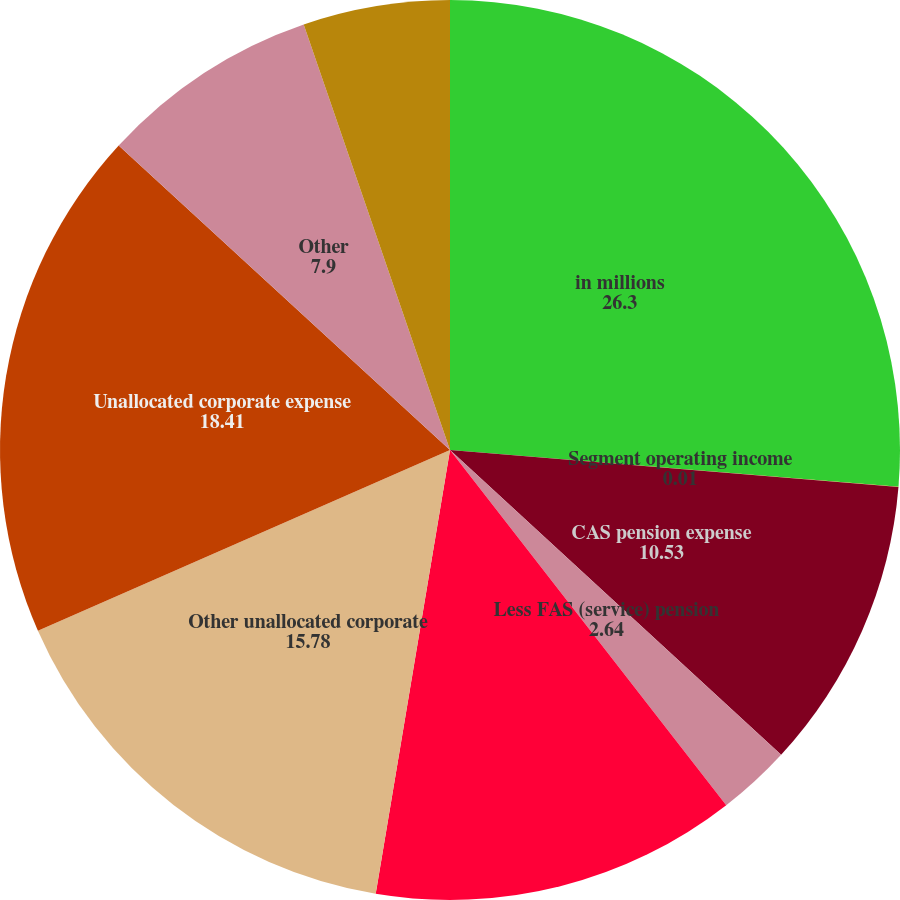Convert chart. <chart><loc_0><loc_0><loc_500><loc_500><pie_chart><fcel>in millions<fcel>Segment operating income<fcel>CAS pension expense<fcel>Less FAS (service) pension<fcel>Net FAS (service)/CAS pension<fcel>Other unallocated corporate<fcel>Unallocated corporate expense<fcel>Other<fcel>Total operating income<nl><fcel>26.3%<fcel>0.01%<fcel>10.53%<fcel>2.64%<fcel>13.16%<fcel>15.78%<fcel>18.41%<fcel>7.9%<fcel>5.27%<nl></chart> 